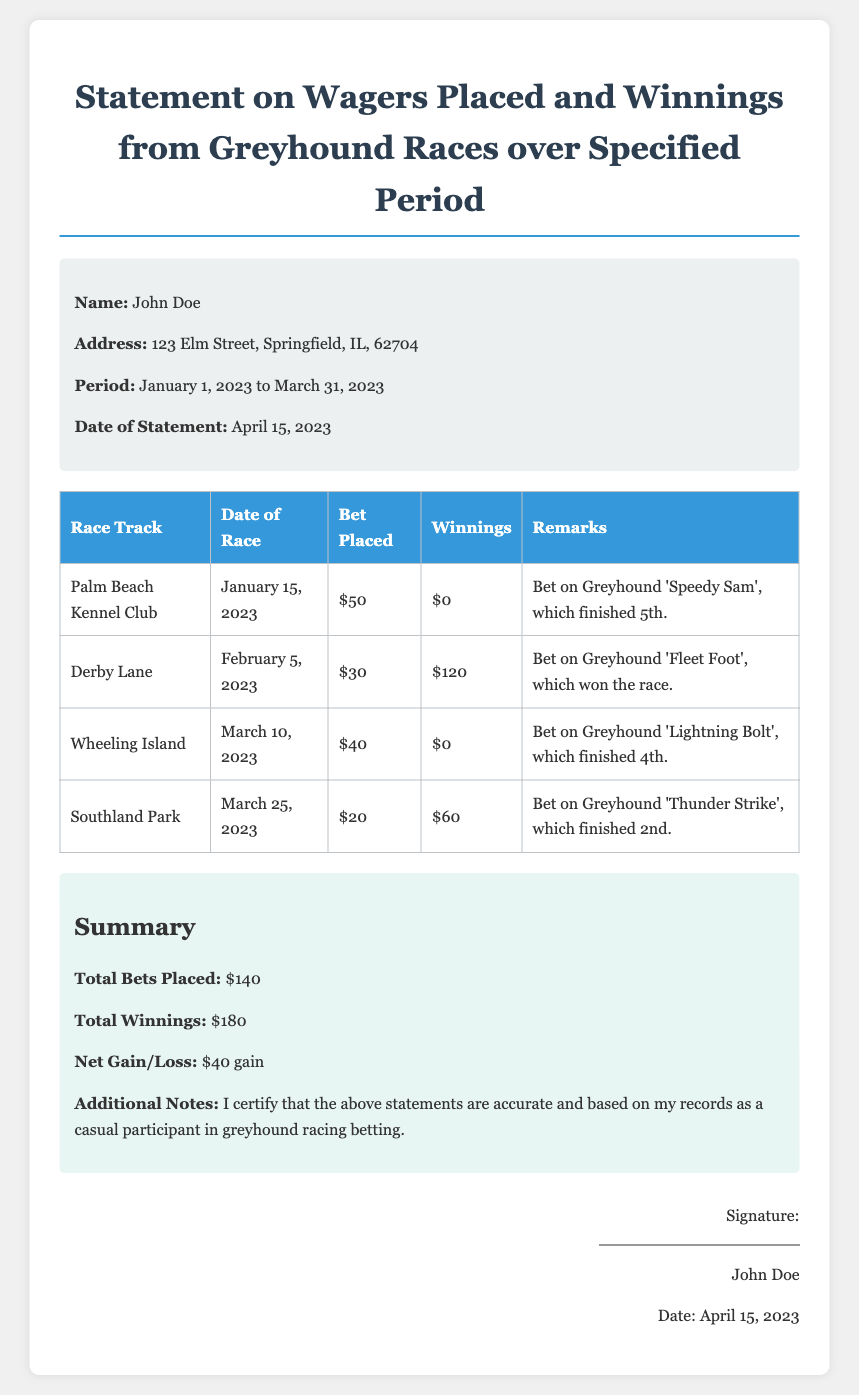What is the name of the person who made the affidavit? The document states the name of the person as John Doe.
Answer: John Doe What is the address provided in the affidavit? The affidavit contains the address of John Doe, which is specified in the personal info section.
Answer: 123 Elm Street, Springfield, IL, 62704 What is the total amount of bets placed during the specified period? The document summarizes the total bets placed based on the table of wagers.
Answer: $140 What date does the specified period start? The document lists the start date of the specified period in the personal info section.
Answer: January 1, 2023 How much did John Doe win on February 5, 2023? The winnings for the bet made on this date are shown in the table.
Answer: $120 What was the net gain or loss reported? The summary section provides a calculation for net gain or loss based on total bets and winnings.
Answer: $40 gain Which greyhound finished last in the first race? The table indicates the position of 'Speedy Sam' in the first race.
Answer: 5th On which date did John Doe place a bet of $20? The document outlines the date of the race and bet amount in the table.
Answer: March 25, 2023 What is the signature date on the affidavit? The signature date is mentioned at the end in the signature section.
Answer: April 15, 2023 